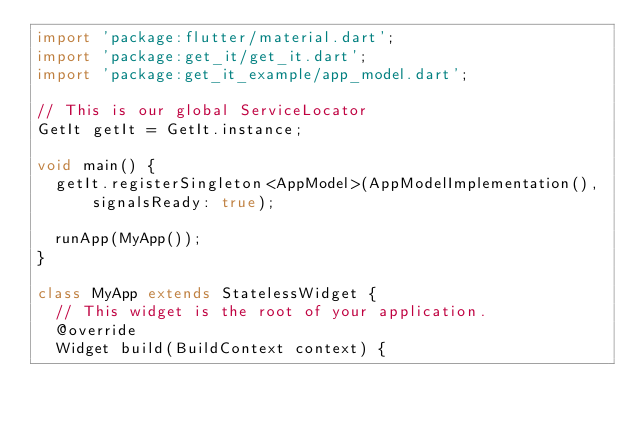<code> <loc_0><loc_0><loc_500><loc_500><_Dart_>import 'package:flutter/material.dart';
import 'package:get_it/get_it.dart';
import 'package:get_it_example/app_model.dart';

// This is our global ServiceLocator
GetIt getIt = GetIt.instance;

void main() {
  getIt.registerSingleton<AppModel>(AppModelImplementation(),
      signalsReady: true);

  runApp(MyApp());
}

class MyApp extends StatelessWidget {
  // This widget is the root of your application.
  @override
  Widget build(BuildContext context) {</code> 